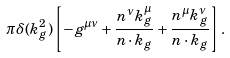<formula> <loc_0><loc_0><loc_500><loc_500>\pi \delta ( k _ { g } ^ { 2 } ) \left [ - g ^ { \mu \nu } + \frac { n ^ { \nu } k _ { g } ^ { \mu } } { n \cdot k _ { g } } + \frac { n ^ { \mu } k _ { g } ^ { \nu } } { n \cdot k _ { g } } \right ] .</formula> 